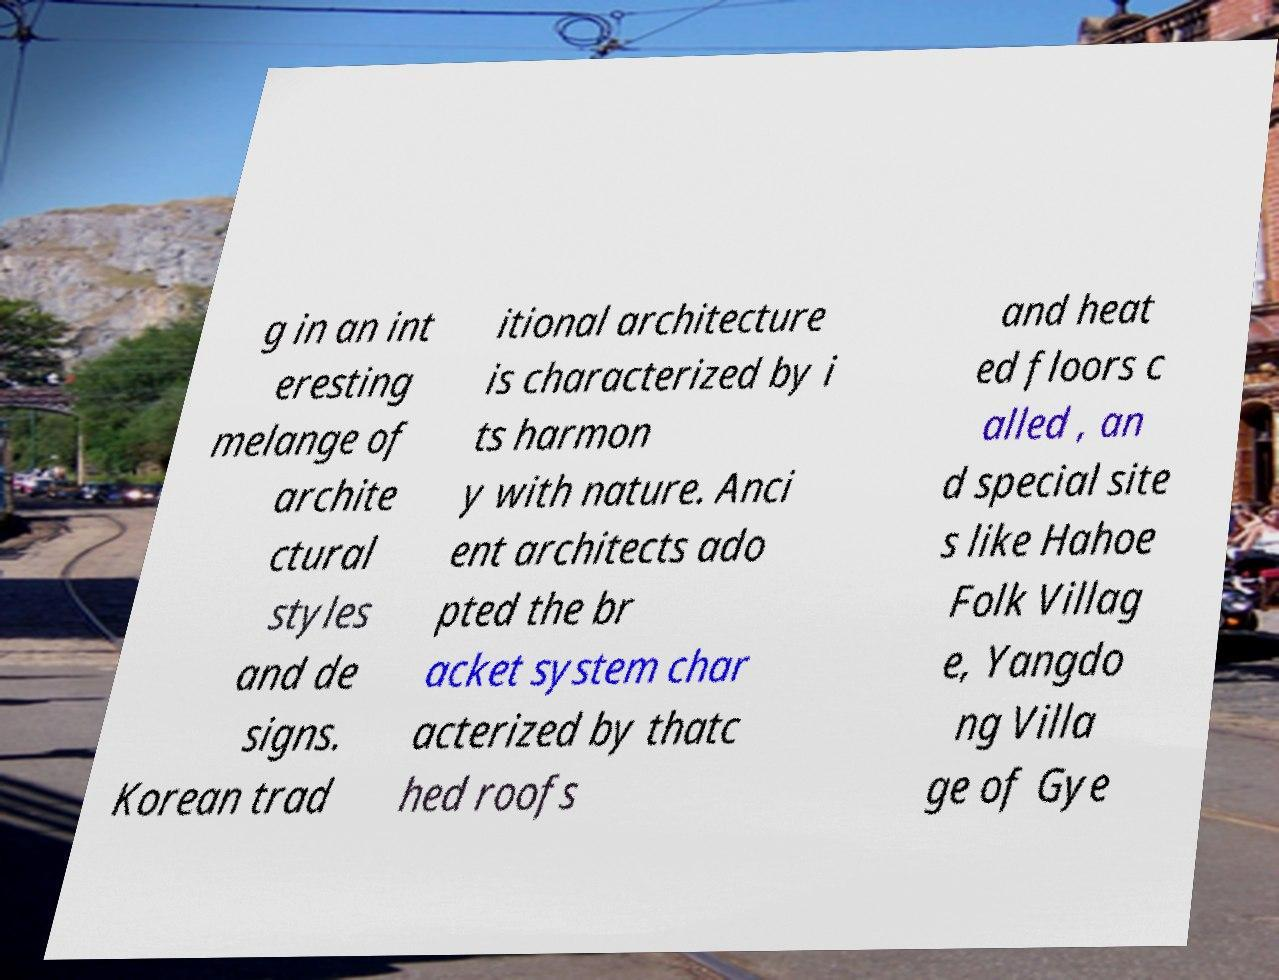Could you extract and type out the text from this image? g in an int eresting melange of archite ctural styles and de signs. Korean trad itional architecture is characterized by i ts harmon y with nature. Anci ent architects ado pted the br acket system char acterized by thatc hed roofs and heat ed floors c alled , an d special site s like Hahoe Folk Villag e, Yangdo ng Villa ge of Gye 